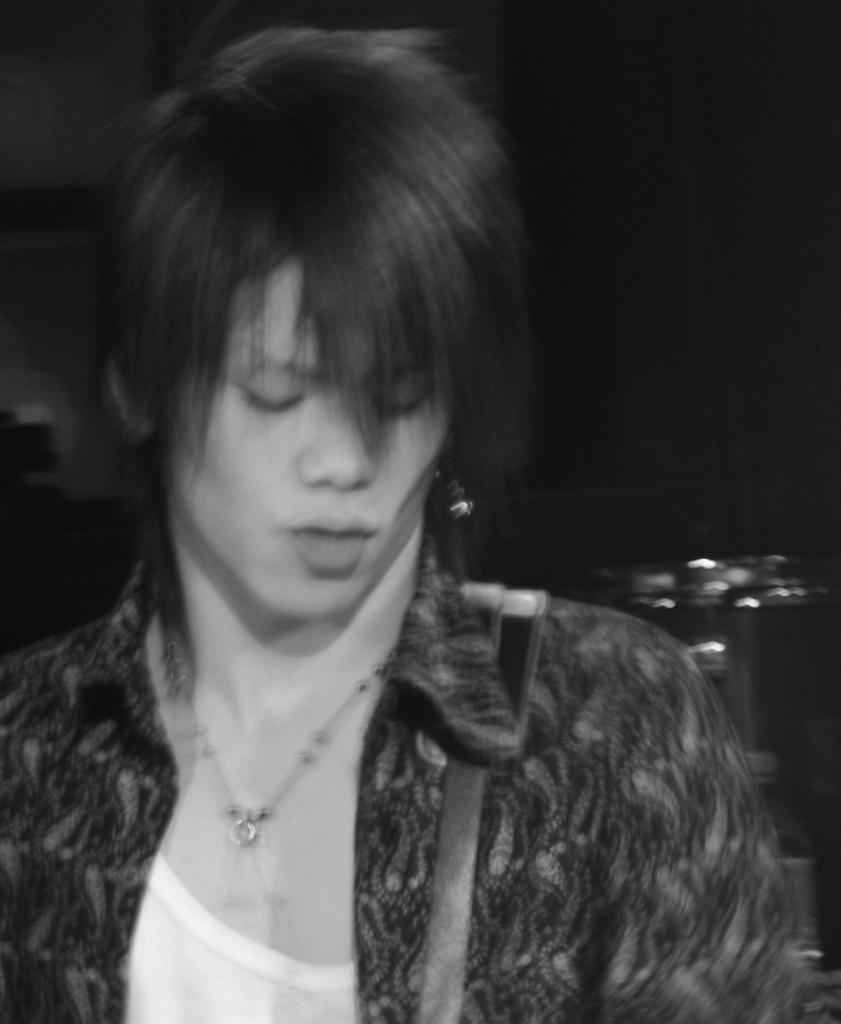What is the main subject of the image? There is a woman in the image. What is the woman doing in the image? The woman is standing. Can you describe any accessory the woman is wearing? The woman has a strap on her shoulder. What can be seen behind the woman in the image? There is an object behind the woman. How would you describe the lighting in the image? The background of the image is dark. How many flies can be seen buzzing around the woman in the image? There are no flies visible in the image. What type of snake is slithering near the woman in the image? There are no snakes present in the image. 